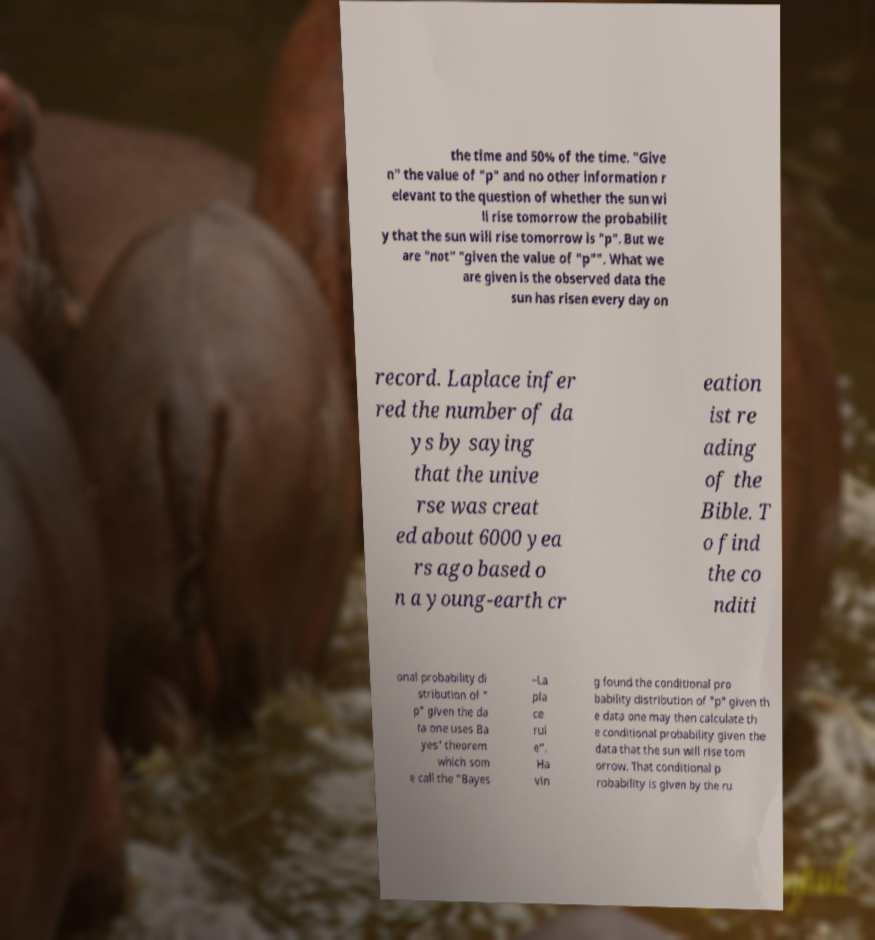Please identify and transcribe the text found in this image. the time and 50% of the time. "Give n" the value of "p" and no other information r elevant to the question of whether the sun wi ll rise tomorrow the probabilit y that the sun will rise tomorrow is "p". But we are "not" "given the value of "p"". What we are given is the observed data the sun has risen every day on record. Laplace infer red the number of da ys by saying that the unive rse was creat ed about 6000 yea rs ago based o n a young-earth cr eation ist re ading of the Bible. T o find the co nditi onal probability di stribution of " p" given the da ta one uses Ba yes' theorem which som e call the "Bayes –La pla ce rul e". Ha vin g found the conditional pro bability distribution of "p" given th e data one may then calculate th e conditional probability given the data that the sun will rise tom orrow. That conditional p robability is given by the ru 